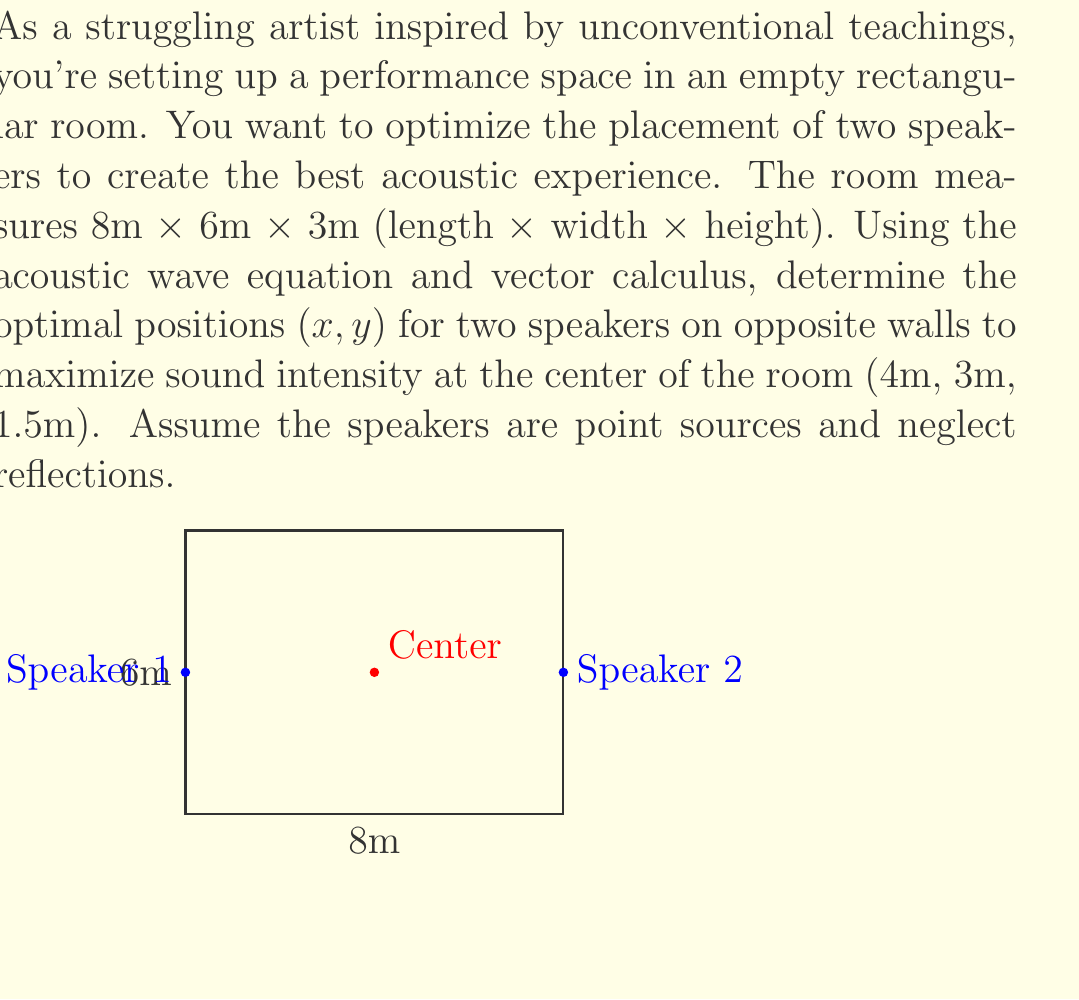Provide a solution to this math problem. Let's approach this step-by-step:

1) The acoustic wave equation in 3D is:

   $$\frac{\partial^2 p}{\partial t^2} = c^2 \nabla^2 p$$

   where $p$ is pressure, $t$ is time, and $c$ is the speed of sound.

2) For a point source in free space, the solution is:

   $$p(r,t) = \frac{A}{r} e^{i(\omega t - kr)}$$

   where $A$ is amplitude, $r$ is distance from the source, $\omega$ is angular frequency, and $k$ is the wave number.

3) The intensity $I$ is proportional to the square of the pressure amplitude:

   $$I \propto |p|^2 = \frac{A^2}{r^2}$$

4) For two speakers, we sum the intensities:

   $$I_{\text{total}} \propto \frac{A^2}{r_1^2} + \frac{A^2}{r_2^2}$$

   where $r_1$ and $r_2$ are distances from the center to each speaker.

5) To maximize $I_{\text{total}}$, we need to minimize $r_1^2 + r_2^2$.

6) For speaker 1 at (0, $y_1$, 1.5) and speaker 2 at (8, $y_2$, 1.5):

   $$r_1^2 = 4^2 + (3-y_1)^2 + 0^2 = 16 + (3-y_1)^2$$
   $$r_2^2 = 4^2 + (3-y_2)^2 + 0^2 = 16 + (3-y_2)^2$$

7) We want to minimize:

   $$f(y_1, y_2) = (16 + (3-y_1)^2) + (16 + (3-y_2)^2)$$

8) Taking partial derivatives and setting to zero:

   $$\frac{\partial f}{\partial y_1} = -2(3-y_1) = 0$$
   $$\frac{\partial f}{\partial y_2} = -2(3-y_2) = 0$$

9) Solving these equations:

   $$y_1 = 3$$
   $$y_2 = 3$$

Therefore, the optimal positions for the speakers are (0, 3, 1.5) and (8, 3, 1.5).
Answer: (0, 3, 1.5) and (8, 3, 1.5) 